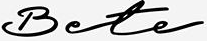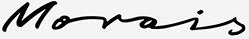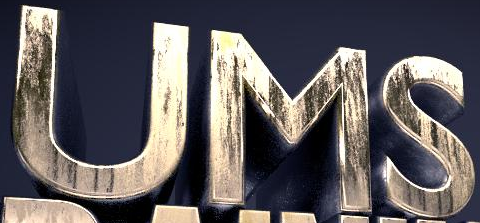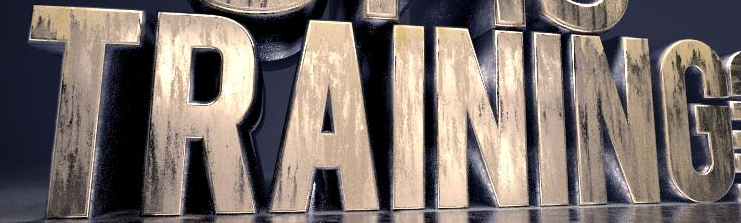What text appears in these images from left to right, separated by a semicolon? Bete; Morois; UMS; TRAINING 